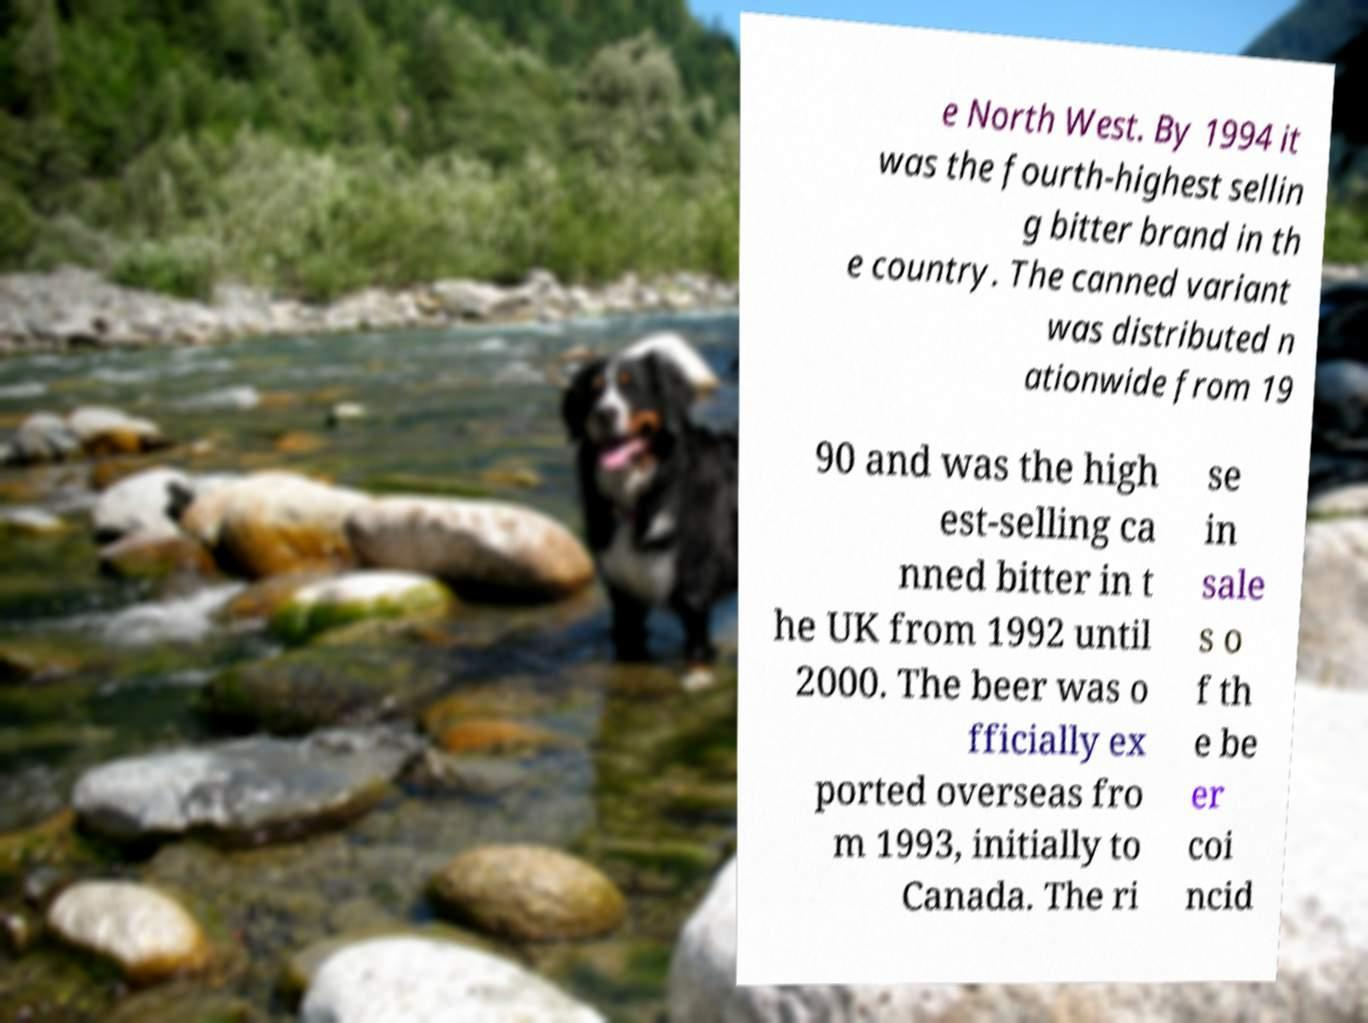What messages or text are displayed in this image? I need them in a readable, typed format. e North West. By 1994 it was the fourth-highest sellin g bitter brand in th e country. The canned variant was distributed n ationwide from 19 90 and was the high est-selling ca nned bitter in t he UK from 1992 until 2000. The beer was o fficially ex ported overseas fro m 1993, initially to Canada. The ri se in sale s o f th e be er coi ncid 